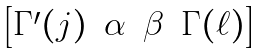<formula> <loc_0><loc_0><loc_500><loc_500>\begin{bmatrix} \Gamma ^ { \prime } ( j ) & \alpha & \beta & \Gamma ( \ell ) \end{bmatrix}</formula> 